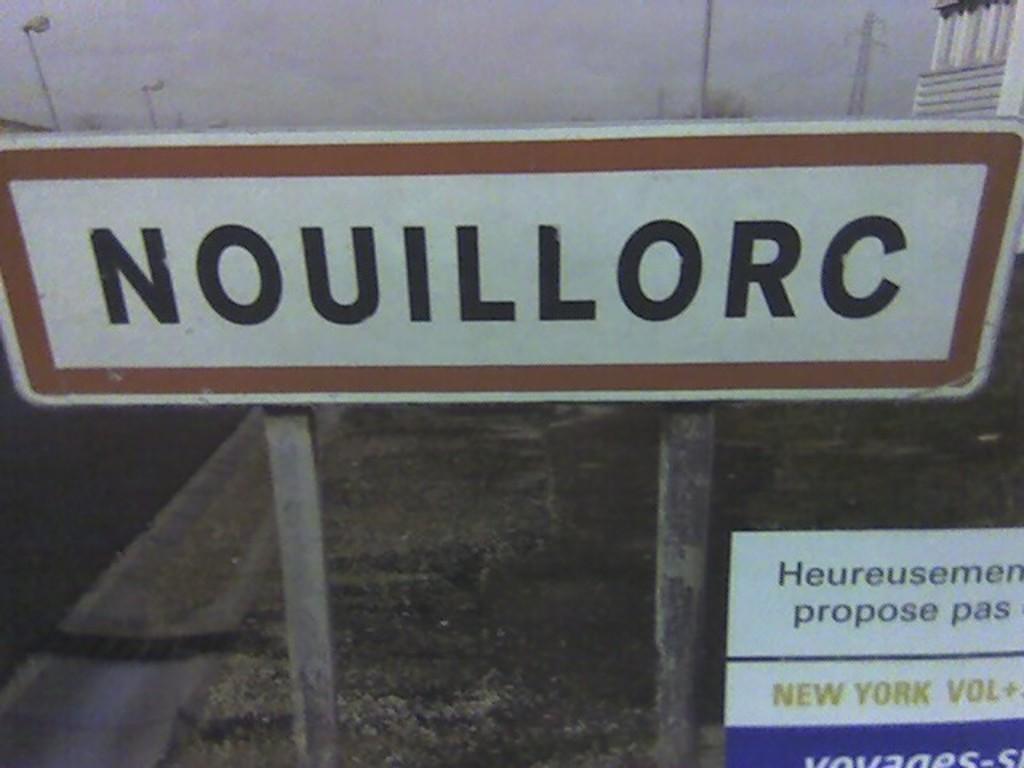What does the sign say?
Ensure brevity in your answer.  Nouillorc. What city can be read in the bottom right?
Provide a succinct answer. New york. 